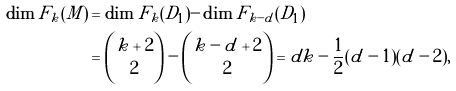<formula> <loc_0><loc_0><loc_500><loc_500>\dim F _ { k } ( M ) & = \dim F _ { k } ( D _ { 1 } ) - \dim F _ { k - d } ( D _ { 1 } ) \\ & = \binom { k + 2 } { 2 } - \binom { k - d + 2 } { 2 } = d k - \frac { 1 } { 2 } ( d - 1 ) ( d - 2 ) ,</formula> 